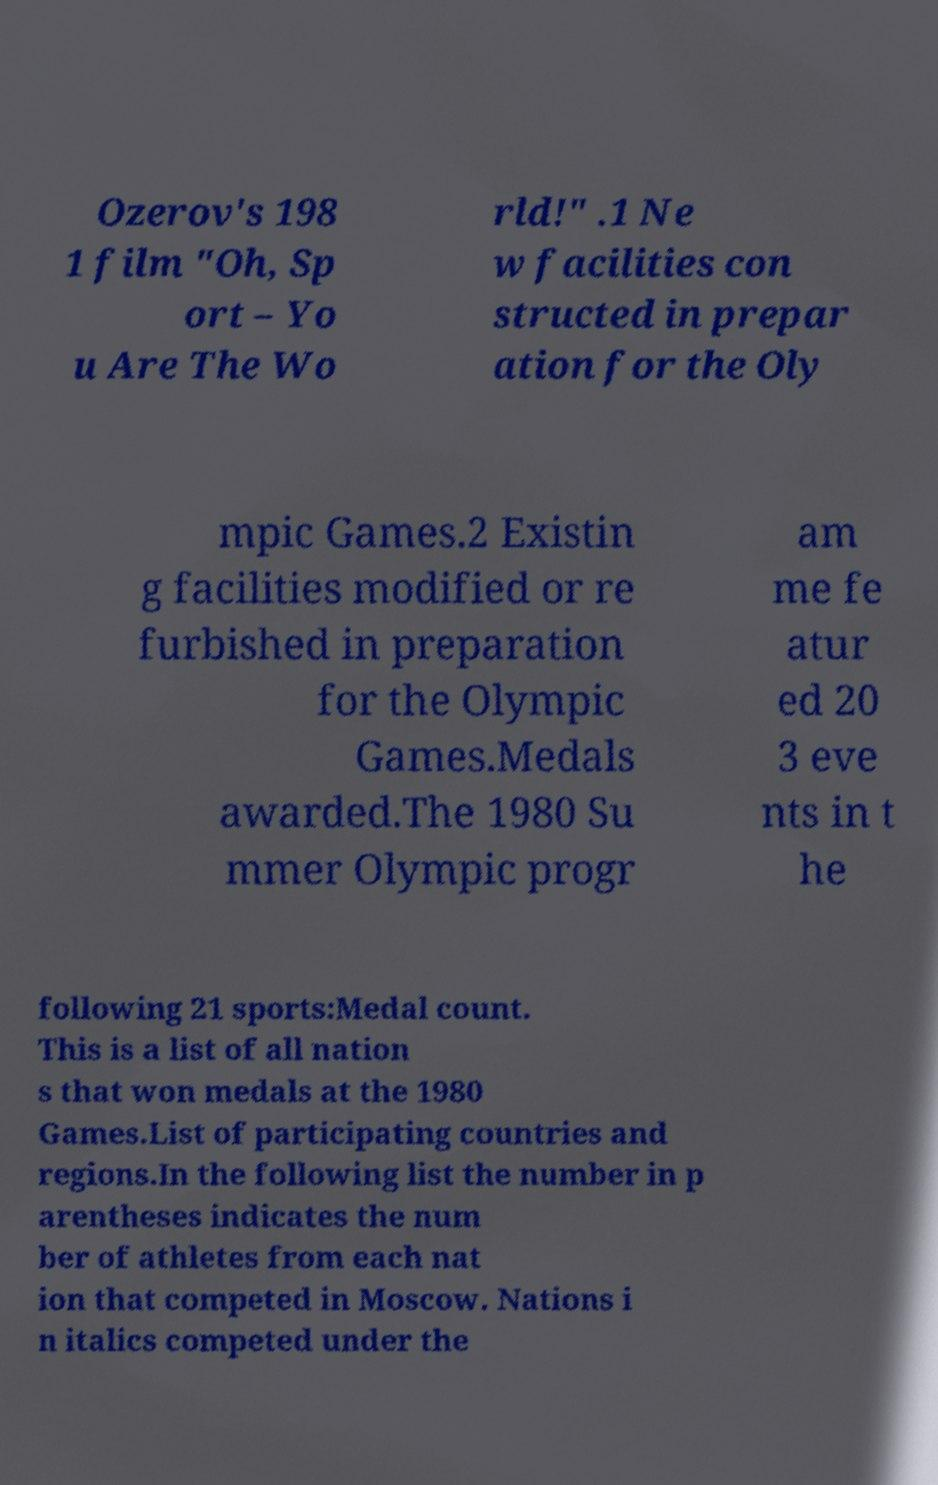Please identify and transcribe the text found in this image. Ozerov's 198 1 film "Oh, Sp ort – Yo u Are The Wo rld!" .1 Ne w facilities con structed in prepar ation for the Oly mpic Games.2 Existin g facilities modified or re furbished in preparation for the Olympic Games.Medals awarded.The 1980 Su mmer Olympic progr am me fe atur ed 20 3 eve nts in t he following 21 sports:Medal count. This is a list of all nation s that won medals at the 1980 Games.List of participating countries and regions.In the following list the number in p arentheses indicates the num ber of athletes from each nat ion that competed in Moscow. Nations i n italics competed under the 